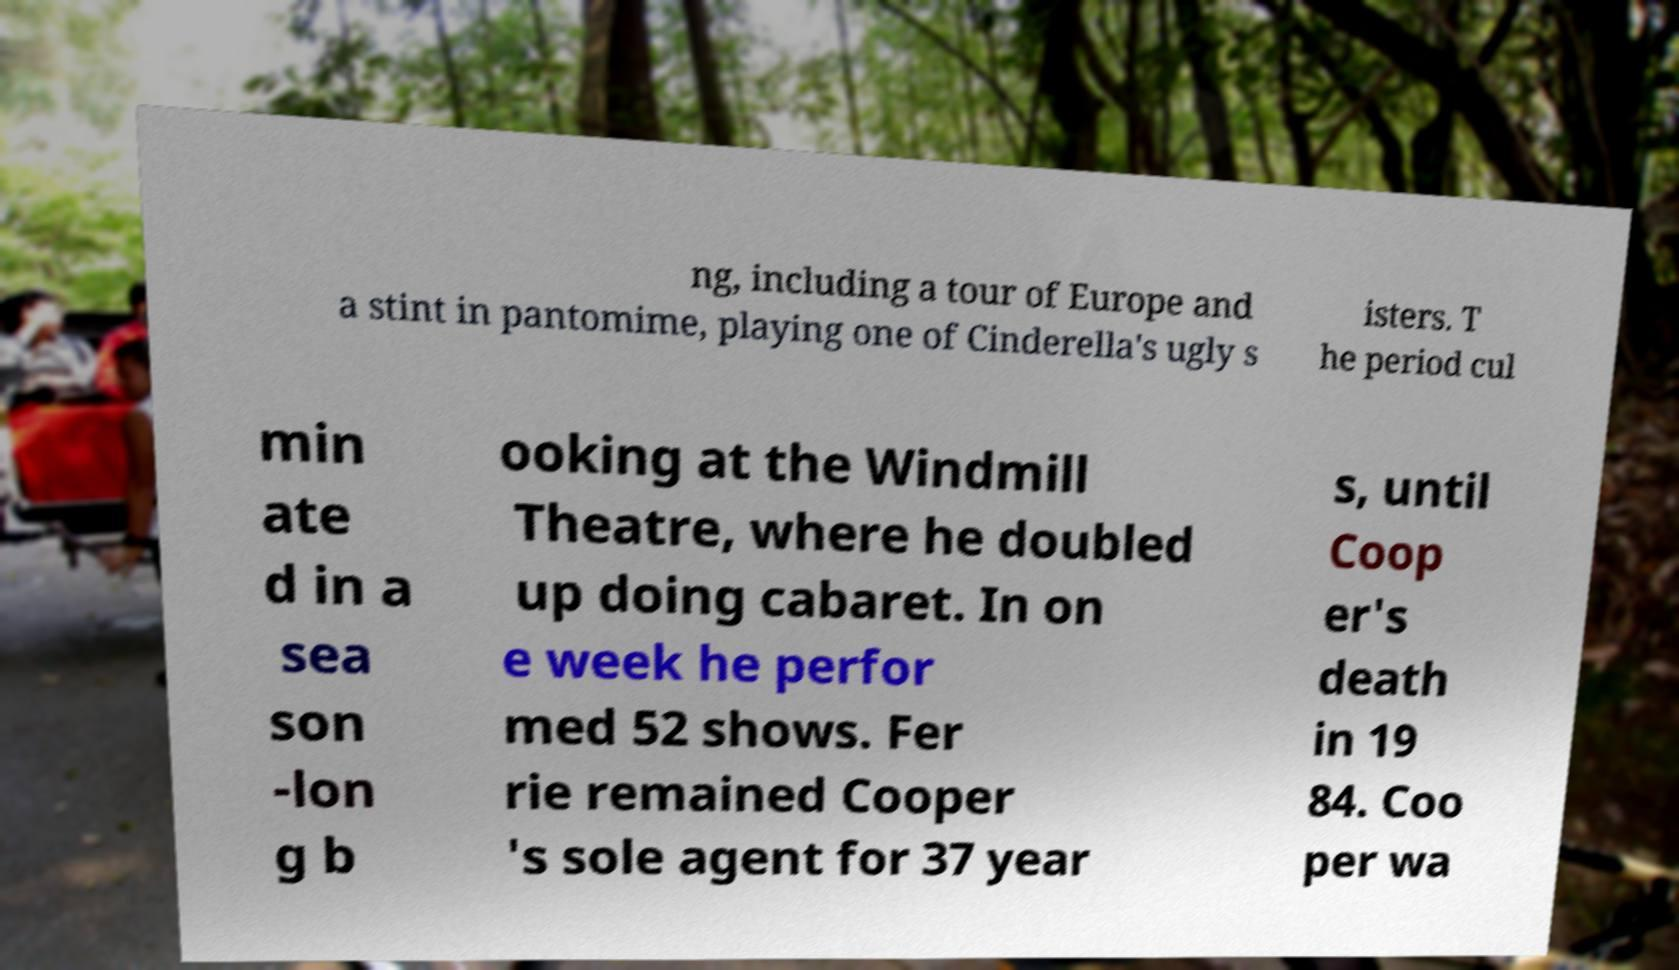What messages or text are displayed in this image? I need them in a readable, typed format. ng, including a tour of Europe and a stint in pantomime, playing one of Cinderella's ugly s isters. T he period cul min ate d in a sea son -lon g b ooking at the Windmill Theatre, where he doubled up doing cabaret. In on e week he perfor med 52 shows. Fer rie remained Cooper 's sole agent for 37 year s, until Coop er's death in 19 84. Coo per wa 